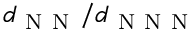Convert formula to latex. <formula><loc_0><loc_0><loc_500><loc_500>d _ { N N } / d _ { N N N }</formula> 